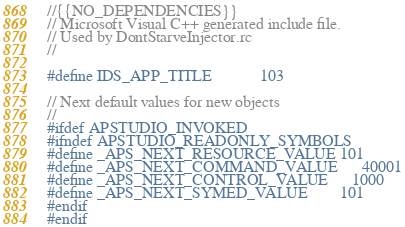Convert code to text. <code><loc_0><loc_0><loc_500><loc_500><_C_>//{{NO_DEPENDENCIES}}
// Microsoft Visual C++ generated include file.
// Used by DontStarveInjector.rc
//

#define IDS_APP_TITLE			103

// Next default values for new objects
//
#ifdef APSTUDIO_INVOKED
#ifndef APSTUDIO_READONLY_SYMBOLS
#define _APS_NEXT_RESOURCE_VALUE	101
#define _APS_NEXT_COMMAND_VALUE		40001
#define _APS_NEXT_CONTROL_VALUE		1000
#define _APS_NEXT_SYMED_VALUE		101
#endif
#endif
</code> 